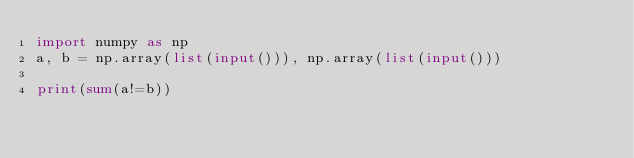Convert code to text. <code><loc_0><loc_0><loc_500><loc_500><_Python_>import numpy as np
a, b = np.array(list(input())), np.array(list(input()))

print(sum(a!=b))</code> 